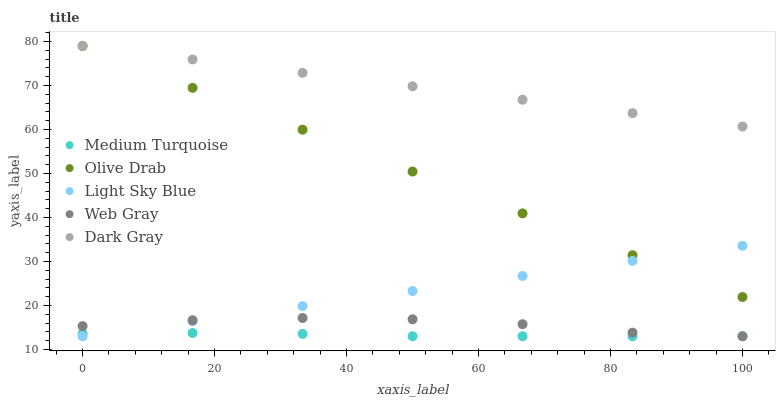Does Medium Turquoise have the minimum area under the curve?
Answer yes or no. Yes. Does Dark Gray have the maximum area under the curve?
Answer yes or no. Yes. Does Light Sky Blue have the minimum area under the curve?
Answer yes or no. No. Does Light Sky Blue have the maximum area under the curve?
Answer yes or no. No. Is Light Sky Blue the smoothest?
Answer yes or no. Yes. Is Web Gray the roughest?
Answer yes or no. Yes. Is Web Gray the smoothest?
Answer yes or no. No. Is Light Sky Blue the roughest?
Answer yes or no. No. Does Light Sky Blue have the lowest value?
Answer yes or no. Yes. Does Olive Drab have the lowest value?
Answer yes or no. No. Does Olive Drab have the highest value?
Answer yes or no. Yes. Does Light Sky Blue have the highest value?
Answer yes or no. No. Is Web Gray less than Dark Gray?
Answer yes or no. Yes. Is Olive Drab greater than Medium Turquoise?
Answer yes or no. Yes. Does Medium Turquoise intersect Light Sky Blue?
Answer yes or no. Yes. Is Medium Turquoise less than Light Sky Blue?
Answer yes or no. No. Is Medium Turquoise greater than Light Sky Blue?
Answer yes or no. No. Does Web Gray intersect Dark Gray?
Answer yes or no. No. 